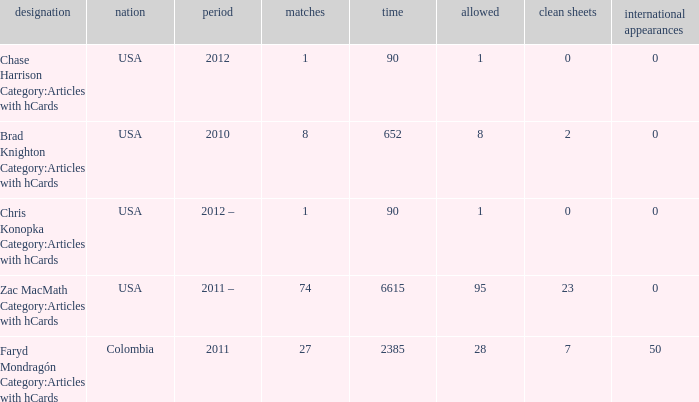When chase harrison category:articles with hcards is the name what is the year? 2012.0. 